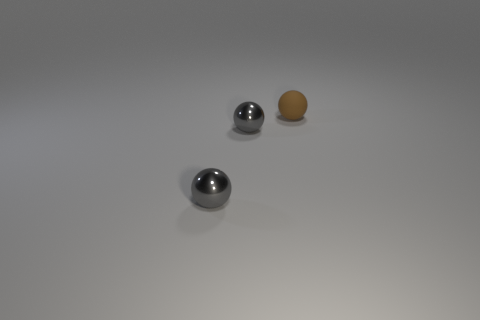Subtract all tiny rubber balls. How many balls are left? 2 Subtract all gray balls. How many balls are left? 1 Add 3 big green rubber cylinders. How many objects exist? 6 Subtract 1 balls. How many balls are left? 2 Add 2 tiny gray balls. How many tiny gray balls are left? 4 Add 1 tiny brown objects. How many tiny brown objects exist? 2 Subtract 0 cyan balls. How many objects are left? 3 Subtract all yellow spheres. Subtract all gray blocks. How many spheres are left? 3 Subtract all purple cylinders. How many green balls are left? 0 Subtract all brown objects. Subtract all tiny matte things. How many objects are left? 1 